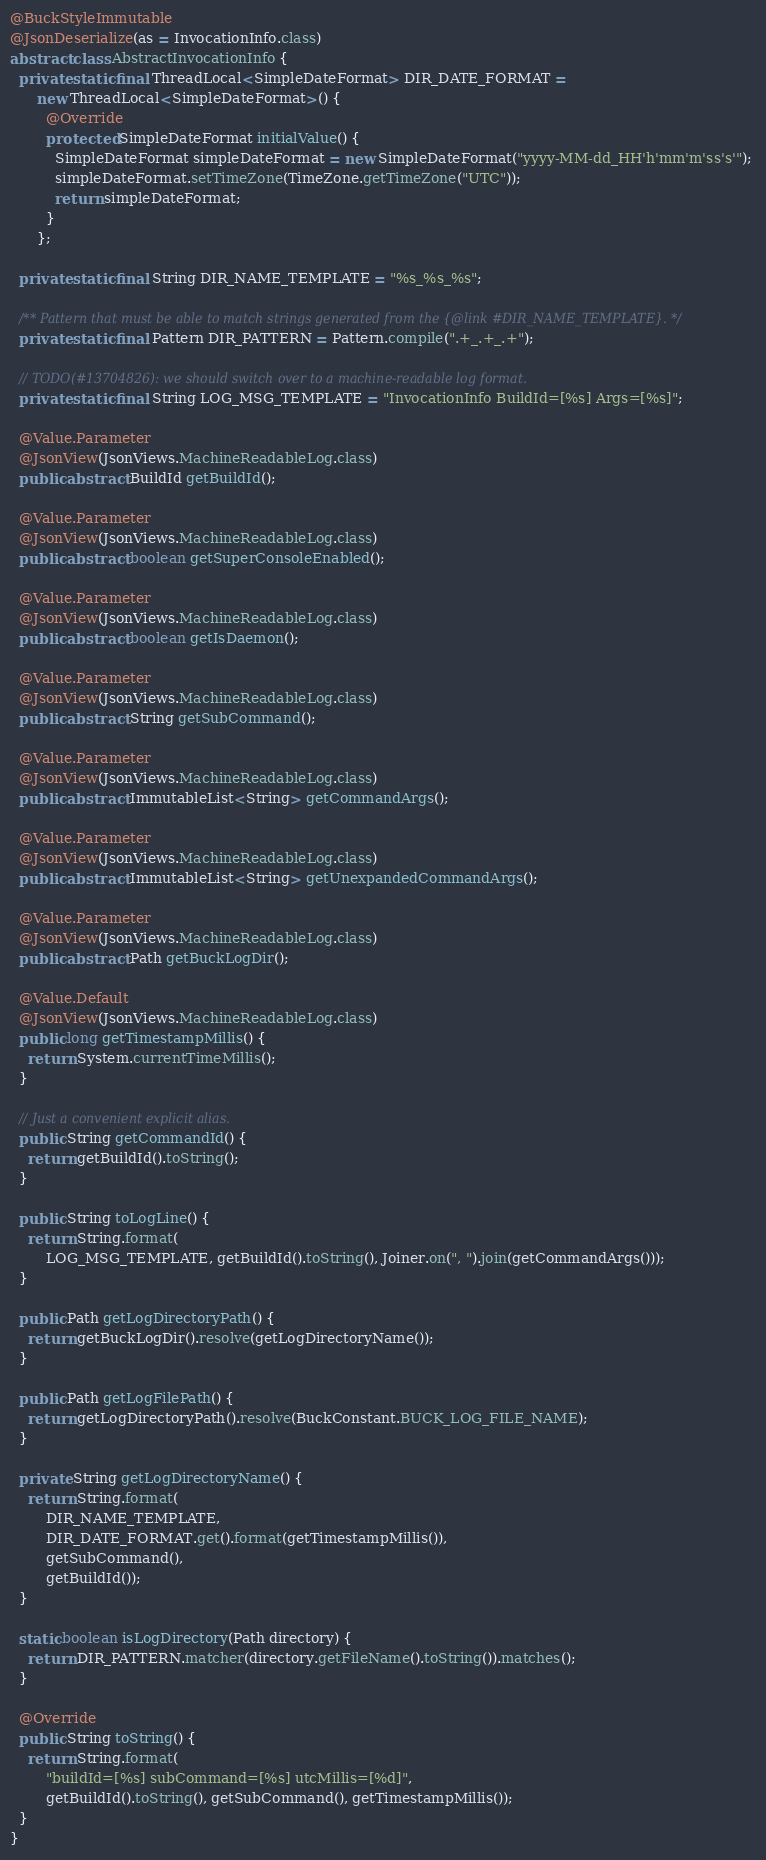Convert code to text. <code><loc_0><loc_0><loc_500><loc_500><_Java_>@BuckStyleImmutable
@JsonDeserialize(as = InvocationInfo.class)
abstract class AbstractInvocationInfo {
  private static final ThreadLocal<SimpleDateFormat> DIR_DATE_FORMAT =
      new ThreadLocal<SimpleDateFormat>() {
        @Override
        protected SimpleDateFormat initialValue() {
          SimpleDateFormat simpleDateFormat = new SimpleDateFormat("yyyy-MM-dd_HH'h'mm'm'ss's'");
          simpleDateFormat.setTimeZone(TimeZone.getTimeZone("UTC"));
          return simpleDateFormat;
        }
      };

  private static final String DIR_NAME_TEMPLATE = "%s_%s_%s";

  /** Pattern that must be able to match strings generated from the {@link #DIR_NAME_TEMPLATE}. */
  private static final Pattern DIR_PATTERN = Pattern.compile(".+_.+_.+");

  // TODO(#13704826): we should switch over to a machine-readable log format.
  private static final String LOG_MSG_TEMPLATE = "InvocationInfo BuildId=[%s] Args=[%s]";

  @Value.Parameter
  @JsonView(JsonViews.MachineReadableLog.class)
  public abstract BuildId getBuildId();

  @Value.Parameter
  @JsonView(JsonViews.MachineReadableLog.class)
  public abstract boolean getSuperConsoleEnabled();

  @Value.Parameter
  @JsonView(JsonViews.MachineReadableLog.class)
  public abstract boolean getIsDaemon();

  @Value.Parameter
  @JsonView(JsonViews.MachineReadableLog.class)
  public abstract String getSubCommand();

  @Value.Parameter
  @JsonView(JsonViews.MachineReadableLog.class)
  public abstract ImmutableList<String> getCommandArgs();

  @Value.Parameter
  @JsonView(JsonViews.MachineReadableLog.class)
  public abstract ImmutableList<String> getUnexpandedCommandArgs();

  @Value.Parameter
  @JsonView(JsonViews.MachineReadableLog.class)
  public abstract Path getBuckLogDir();

  @Value.Default
  @JsonView(JsonViews.MachineReadableLog.class)
  public long getTimestampMillis() {
    return System.currentTimeMillis();
  }

  // Just a convenient explicit alias.
  public String getCommandId() {
    return getBuildId().toString();
  }

  public String toLogLine() {
    return String.format(
        LOG_MSG_TEMPLATE, getBuildId().toString(), Joiner.on(", ").join(getCommandArgs()));
  }

  public Path getLogDirectoryPath() {
    return getBuckLogDir().resolve(getLogDirectoryName());
  }

  public Path getLogFilePath() {
    return getLogDirectoryPath().resolve(BuckConstant.BUCK_LOG_FILE_NAME);
  }

  private String getLogDirectoryName() {
    return String.format(
        DIR_NAME_TEMPLATE,
        DIR_DATE_FORMAT.get().format(getTimestampMillis()),
        getSubCommand(),
        getBuildId());
  }

  static boolean isLogDirectory(Path directory) {
    return DIR_PATTERN.matcher(directory.getFileName().toString()).matches();
  }

  @Override
  public String toString() {
    return String.format(
        "buildId=[%s] subCommand=[%s] utcMillis=[%d]",
        getBuildId().toString(), getSubCommand(), getTimestampMillis());
  }
}
</code> 